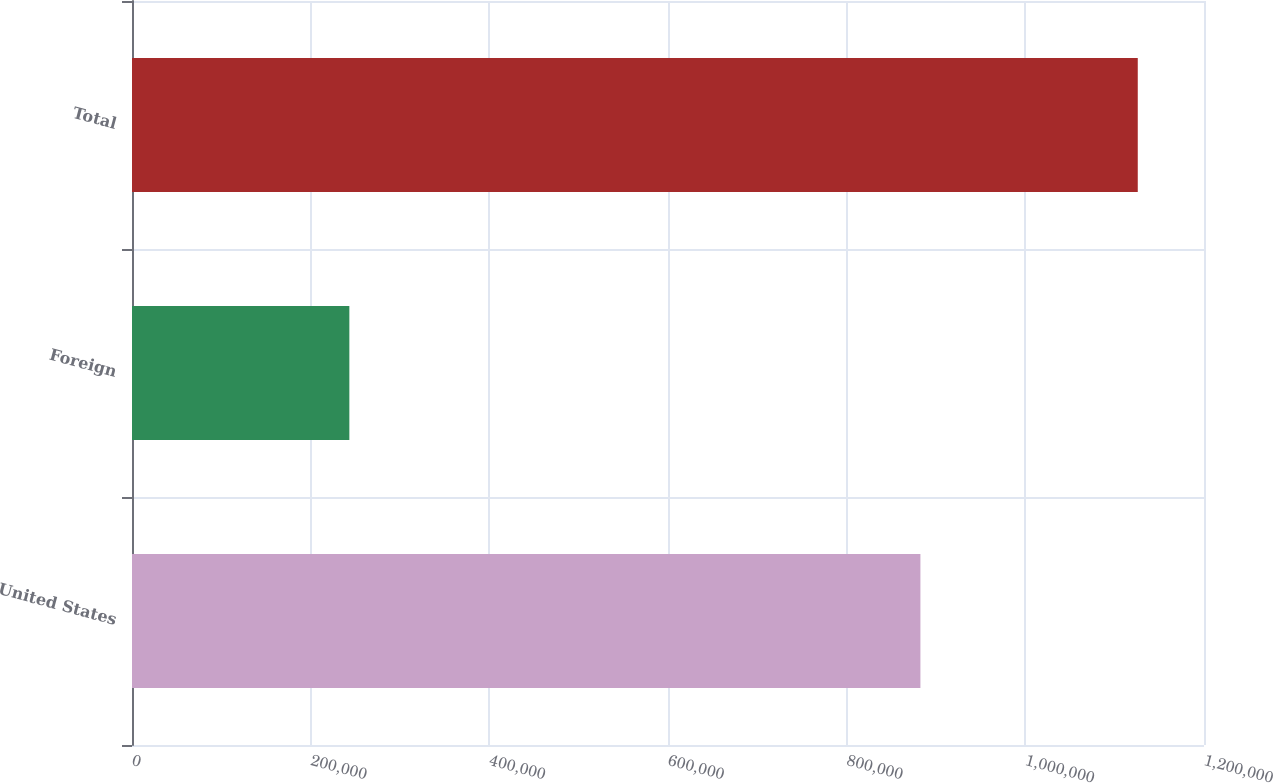<chart> <loc_0><loc_0><loc_500><loc_500><bar_chart><fcel>United States<fcel>Foreign<fcel>Total<nl><fcel>882552<fcel>243308<fcel>1.12586e+06<nl></chart> 